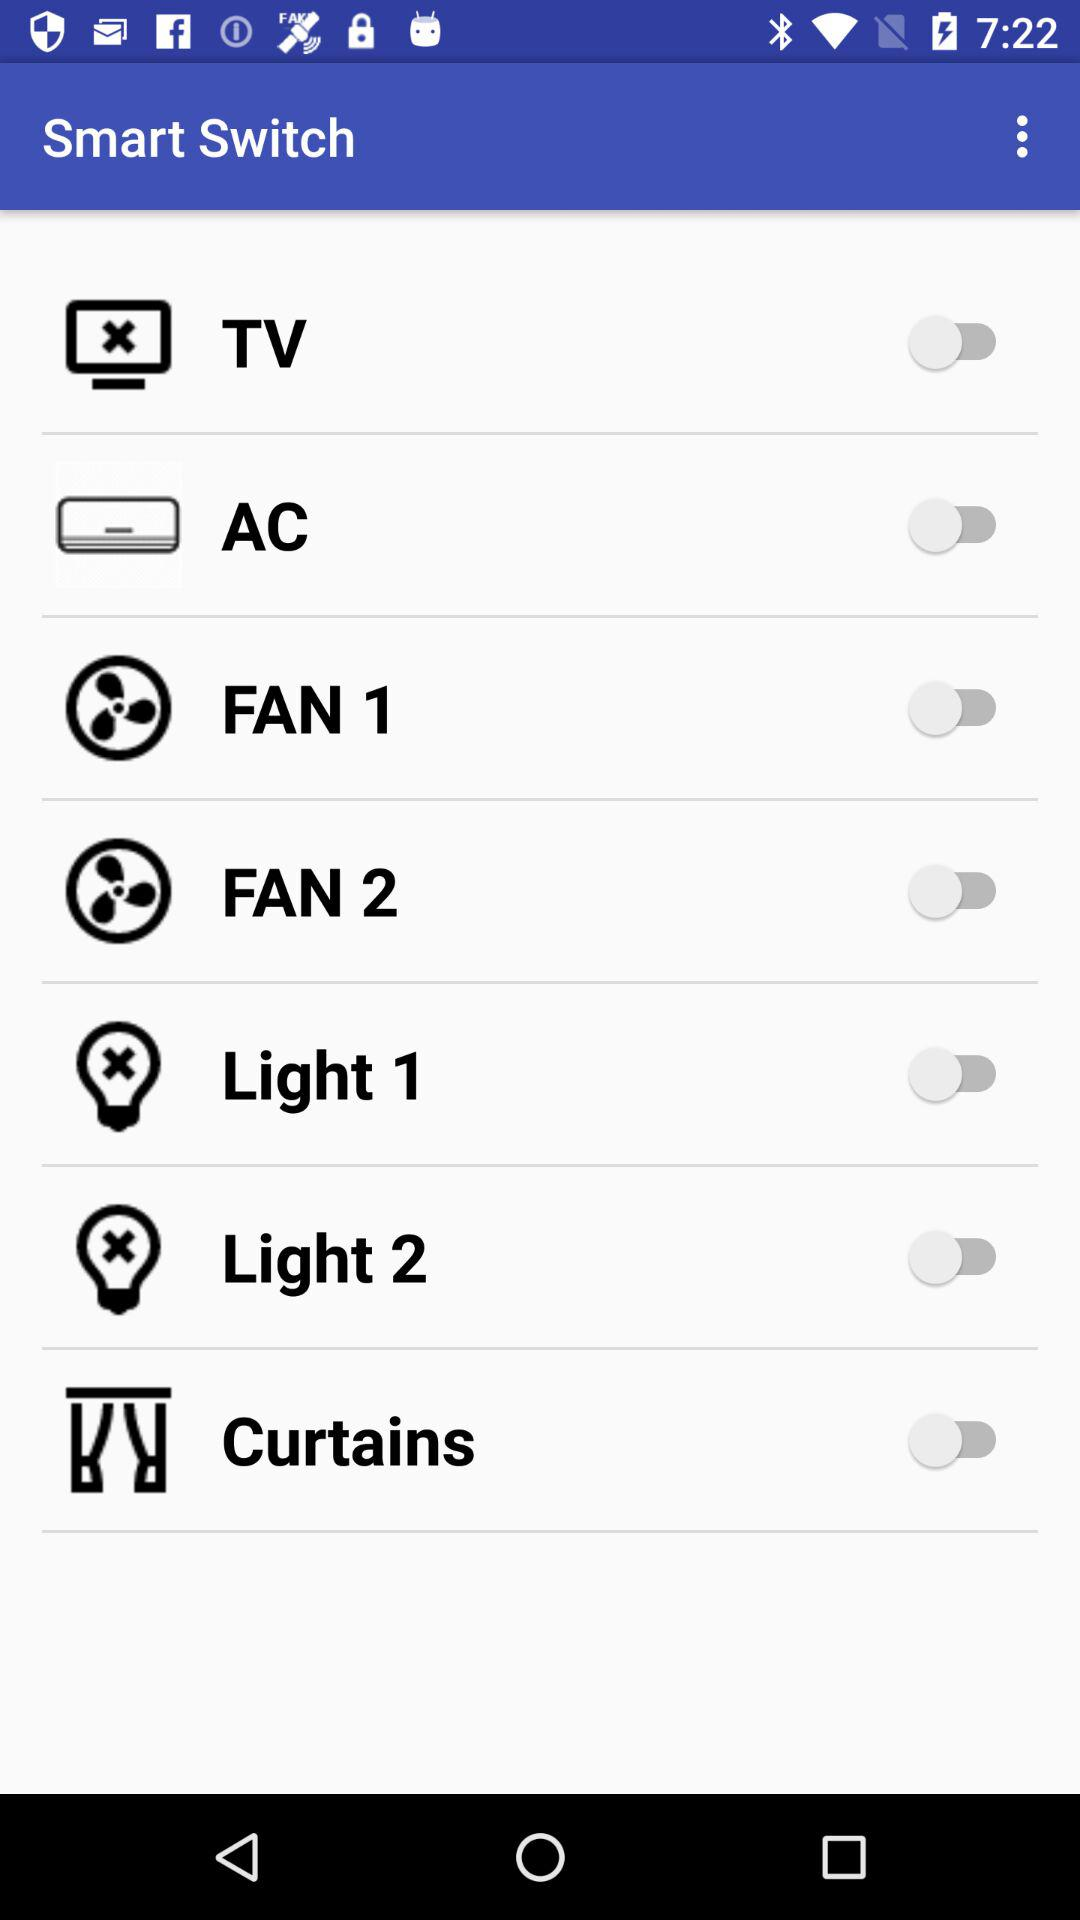Which electric appliances can be activated? Electric appliances that can be activated are "TV", "AC", "FAN 1", "FAN 2", "Light 1", "Light 2" and "Curtains". 